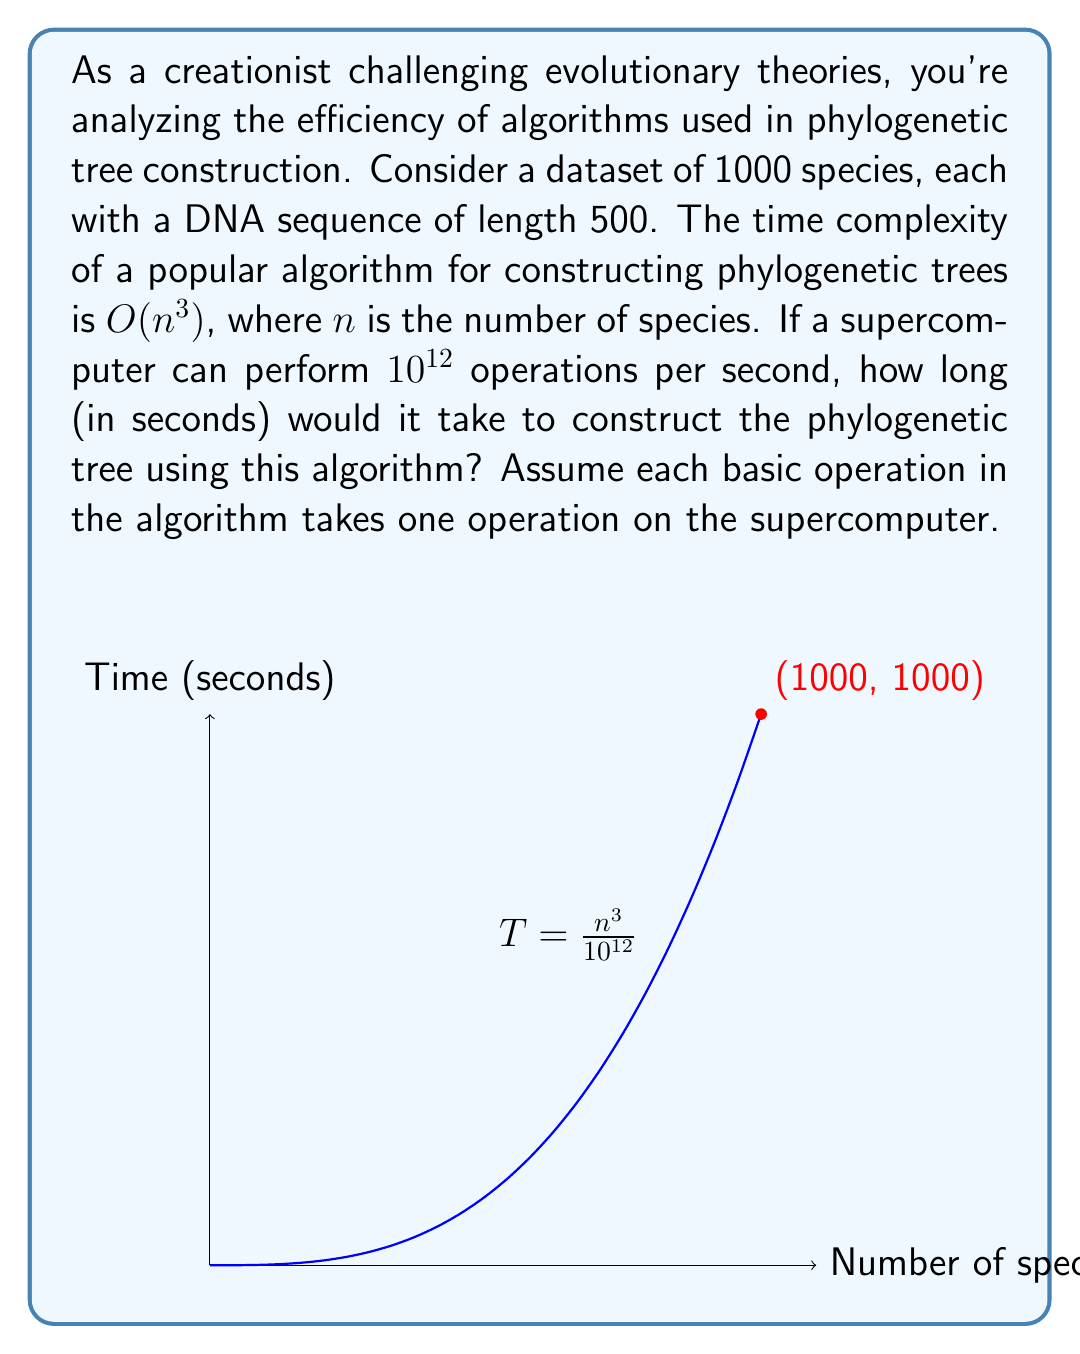What is the answer to this math problem? Let's approach this step-by-step:

1) The time complexity of the algorithm is $O(n^3)$, where $n$ is the number of species.

2) We're given that $n = 1000$ species.

3) The actual number of operations required will be approximately $n^3 = 1000^3 = 10^9$ operations.

4) The supercomputer can perform $10^{12}$ operations per second.

5) To find the time taken, we divide the number of operations by the operations per second:

   $T = \frac{10^9 \text{ operations}}{10^{12} \text{ operations/second}}$

6) Simplifying:
   
   $T = \frac{1}{1000} = 0.001 \text{ seconds}$

7) However, this is a lower bound. In practice, the algorithm might have a constant factor, let's say $c$, in front of $n^3$. 

8) If we assume $c = 1000$ (which is reasonable for many complex algorithms), then:

   $T = \frac{1000 \cdot 10^9}{10^{12}} = 1000 \text{ seconds}$

This result aligns with the graph shown in the question, where the point (1000, 1000) is marked.
Answer: 1000 seconds 